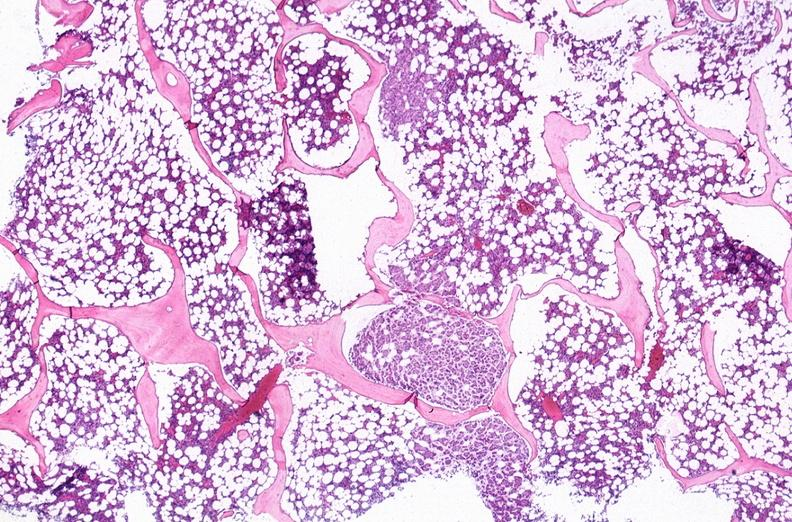s hematologic present?
Answer the question using a single word or phrase. Yes 